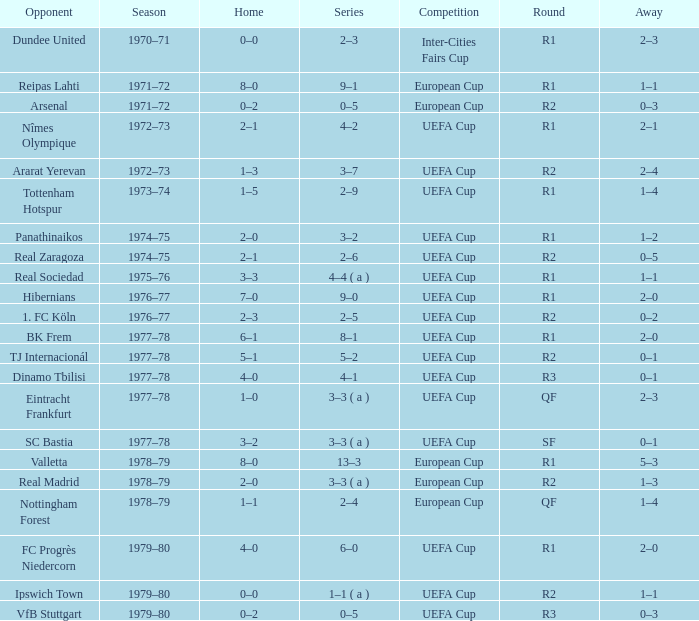Which Season has an Opponent of hibernians? 1976–77. 